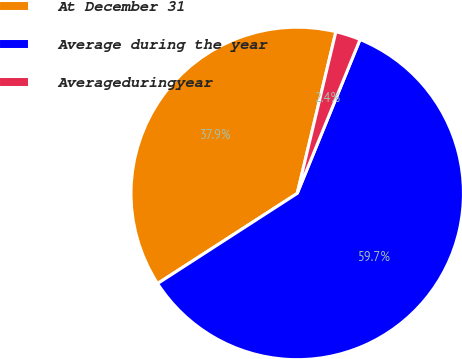Convert chart to OTSL. <chart><loc_0><loc_0><loc_500><loc_500><pie_chart><fcel>At December 31<fcel>Average during the year<fcel>Averageduringyear<nl><fcel>37.86%<fcel>59.71%<fcel>2.43%<nl></chart> 